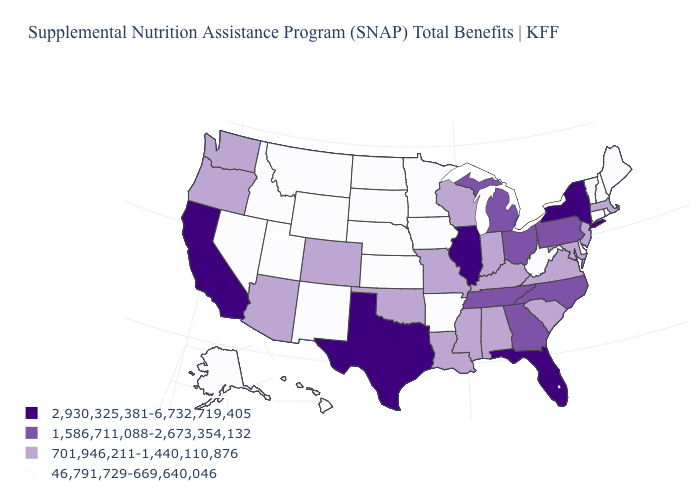What is the value of Ohio?
Give a very brief answer. 1,586,711,088-2,673,354,132. Name the states that have a value in the range 46,791,729-669,640,046?
Concise answer only. Alaska, Arkansas, Connecticut, Delaware, Hawaii, Idaho, Iowa, Kansas, Maine, Minnesota, Montana, Nebraska, Nevada, New Hampshire, New Mexico, North Dakota, Rhode Island, South Dakota, Utah, Vermont, West Virginia, Wyoming. Does the first symbol in the legend represent the smallest category?
Write a very short answer. No. What is the value of Connecticut?
Quick response, please. 46,791,729-669,640,046. Does Nebraska have a lower value than Idaho?
Write a very short answer. No. Which states have the highest value in the USA?
Answer briefly. California, Florida, Illinois, New York, Texas. Which states have the lowest value in the West?
Quick response, please. Alaska, Hawaii, Idaho, Montana, Nevada, New Mexico, Utah, Wyoming. What is the value of Massachusetts?
Short answer required. 701,946,211-1,440,110,876. What is the lowest value in the USA?
Concise answer only. 46,791,729-669,640,046. Does New Hampshire have the lowest value in the Northeast?
Quick response, please. Yes. Does Kentucky have the highest value in the USA?
Answer briefly. No. What is the lowest value in states that border Nebraska?
Give a very brief answer. 46,791,729-669,640,046. What is the value of Washington?
Write a very short answer. 701,946,211-1,440,110,876. Does Utah have the lowest value in the USA?
Answer briefly. Yes. Which states have the highest value in the USA?
Concise answer only. California, Florida, Illinois, New York, Texas. 